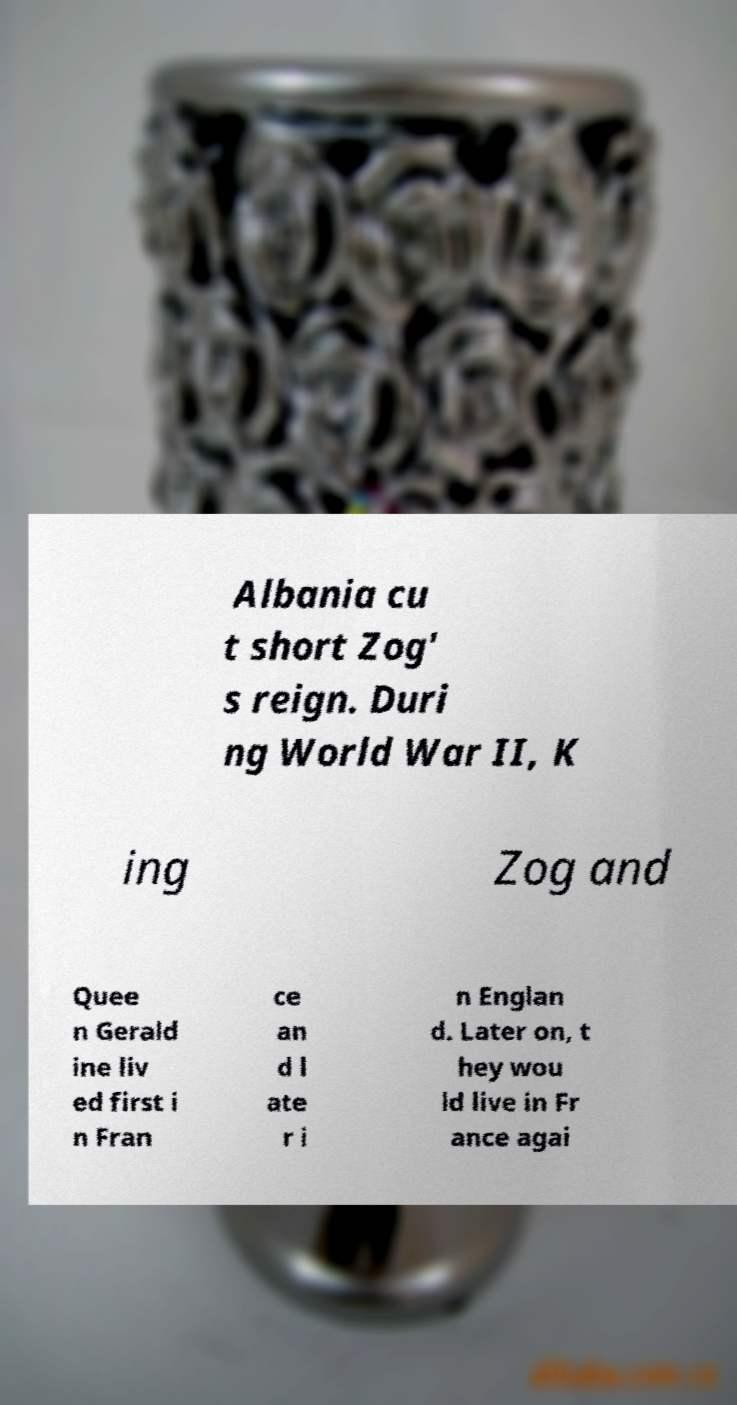Can you read and provide the text displayed in the image?This photo seems to have some interesting text. Can you extract and type it out for me? Albania cu t short Zog' s reign. Duri ng World War II, K ing Zog and Quee n Gerald ine liv ed first i n Fran ce an d l ate r i n Englan d. Later on, t hey wou ld live in Fr ance agai 